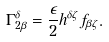<formula> <loc_0><loc_0><loc_500><loc_500>\Gamma ^ { \delta } _ { 2 \beta } = \frac { \epsilon } { 2 } h ^ { \delta \zeta } f _ { \beta \zeta } .</formula> 